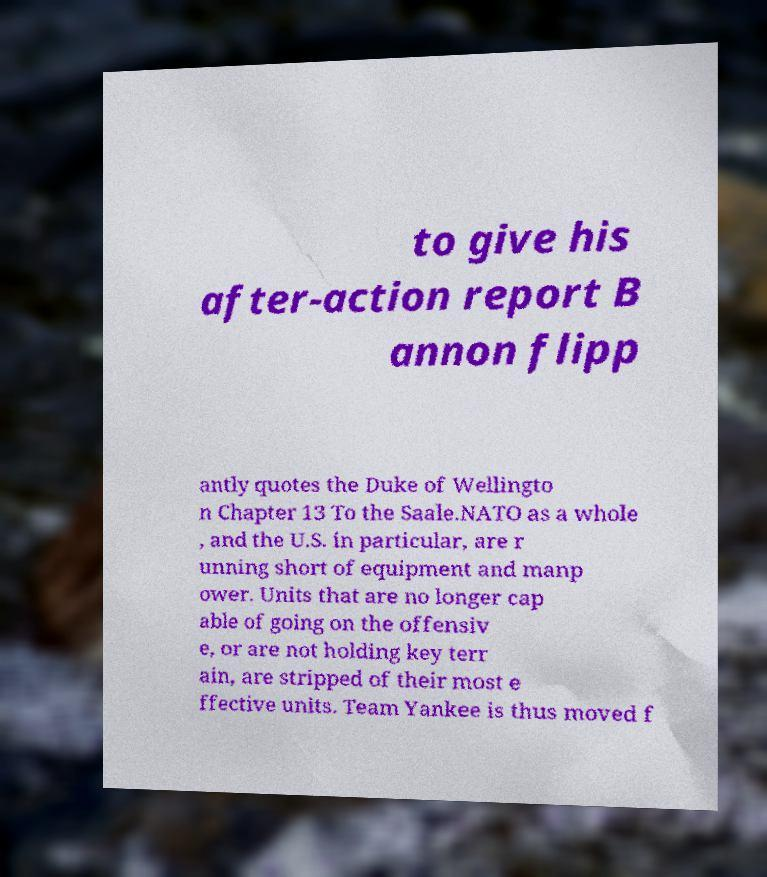There's text embedded in this image that I need extracted. Can you transcribe it verbatim? to give his after-action report B annon flipp antly quotes the Duke of Wellingto n Chapter 13 To the Saale.NATO as a whole , and the U.S. in particular, are r unning short of equipment and manp ower. Units that are no longer cap able of going on the offensiv e, or are not holding key terr ain, are stripped of their most e ffective units. Team Yankee is thus moved f 